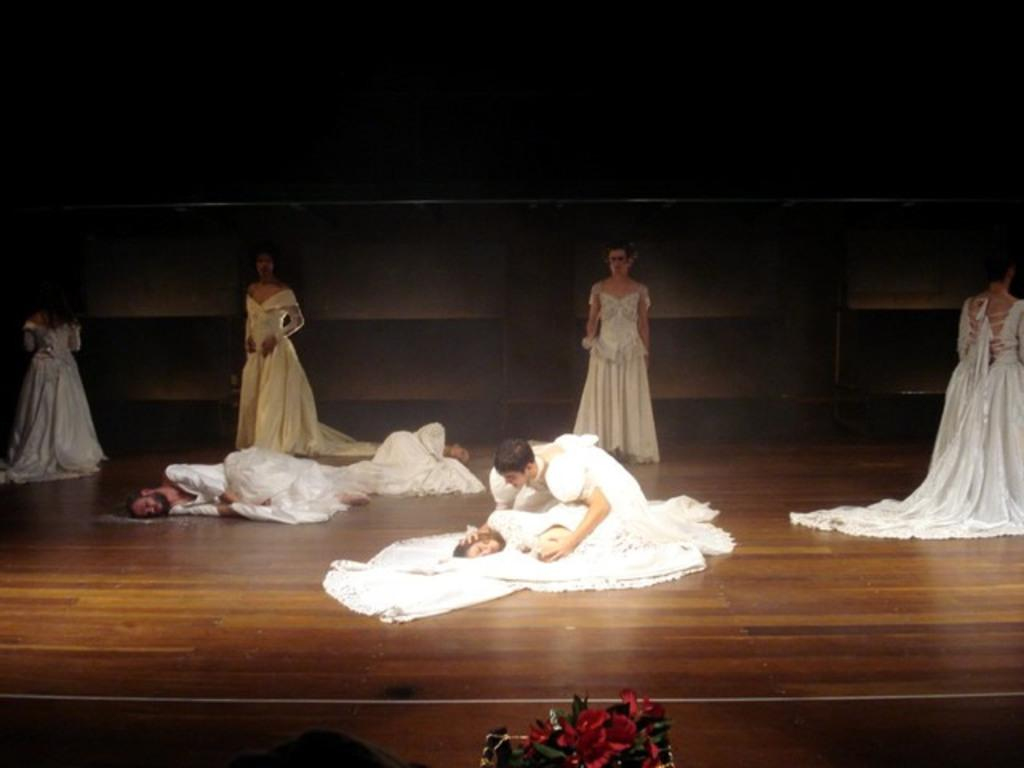What is happening on the stage in the image? There are people performing on the stage in the image. What are the performers wearing? The performers are wearing costumes. Can you describe the position of the three persons in the image? There are three persons laying down in the image. What type of vegetation can be seen at the bottom of the image? Flowers and leaves are visible at the bottom of the image. What type of footwear is visible on the trail in the image? There is no trail or footwear present in the image. How does the sleet affect the performance on the stage in the image? There is no sleet present in the image, so it does not affect the performance. 